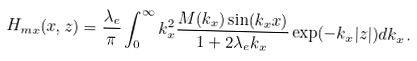<formula> <loc_0><loc_0><loc_500><loc_500>H _ { m x } ( x , z ) = \frac { \lambda _ { e } } { \pi } \int _ { 0 } ^ { \infty } k _ { x } ^ { 2 } \frac { M ( k _ { x } ) \sin ( k _ { x } x ) } { 1 + 2 \lambda _ { e } k _ { x } } \exp ( - k _ { x } | z | ) d k _ { x } \, .</formula> 